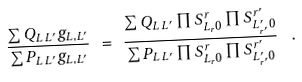<formula> <loc_0><loc_0><loc_500><loc_500>\frac { \sum Q _ { L \, L ^ { \prime } } g _ { L , L ^ { \prime } } } { \sum P _ { L \, L ^ { \prime } } g _ { L , L ^ { \prime } } } \ = \ \frac { \sum Q _ { L \, L ^ { \prime } } \prod S ^ { r } _ { L _ { r } 0 } \prod S ^ { r ^ { \prime } } _ { L ^ { \prime } _ { r ^ { \prime } } 0 } } { \sum P _ { L \, L ^ { \prime } } \prod S ^ { r } _ { L _ { r } 0 } \prod S ^ { r ^ { \prime } } _ { L ^ { \prime } _ { r ^ { \prime } } 0 } } \ \ .</formula> 